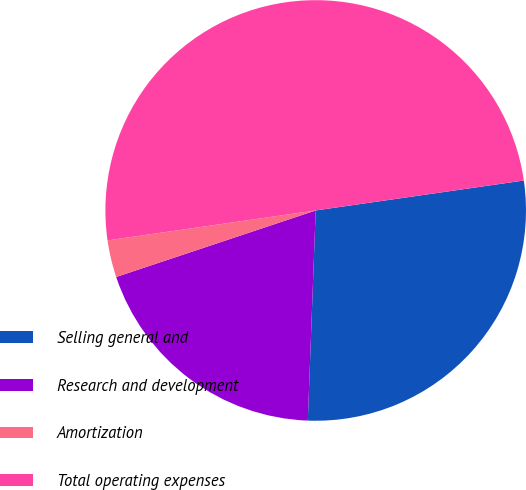Convert chart. <chart><loc_0><loc_0><loc_500><loc_500><pie_chart><fcel>Selling general and<fcel>Research and development<fcel>Amortization<fcel>Total operating expenses<nl><fcel>27.87%<fcel>19.28%<fcel>2.85%<fcel>50.0%<nl></chart> 